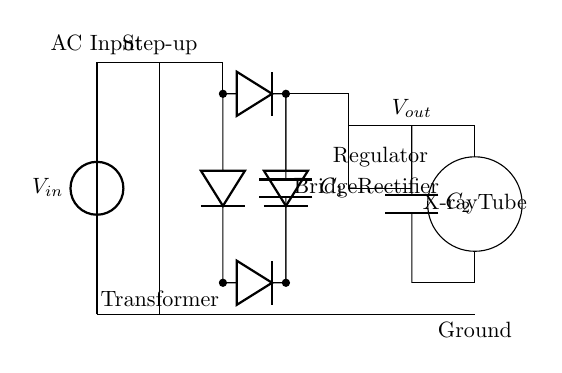What is the input voltage of the circuit? The input voltage is labeled as V_in at the source and represents the voltage provided to the circuit from the AC supply.
Answer: V_in What component converts AC voltage to DC voltage? The component that converts AC voltage to DC voltage in the circuit is the bridge rectifier. It consists of four diodes arranged in a bridge configuration.
Answer: Bridge Rectifier What is the purpose of the smoothing capacitor? The smoothing capacitor serves to reduce voltage ripple by storing charge and releasing it slowly, thereby stabilizing the voltage output after rectification.
Answer: Stabilizing voltage Which component regulates the voltage output? The component that regulates the voltage output is marked as "Regulator" in the diagram; it ensures a consistent voltage is supplied to the load.
Answer: Regulator What is the load in this circuit? The load in this circuit is the X-ray tube, which is the component that utilizes the electrical energy to generate X-rays for dental imaging.
Answer: X-ray Tube What is the function of the transformer in this circuit? The transformer is used to step up the input voltage to a higher level suitable for the X-ray tube operation, as indicated by the label "Step-up."
Answer: Step-up How many diodes are used in the bridge rectifier? The bridge rectifier consists of four diodes arranged to allow current to flow in one direction, providing the necessary functionality to convert AC to DC.
Answer: Four diodes 